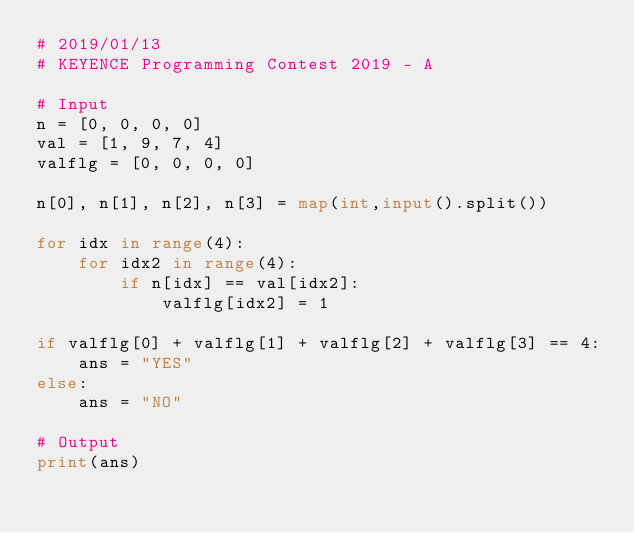Convert code to text. <code><loc_0><loc_0><loc_500><loc_500><_Python_># 2019/01/13
# KEYENCE Programming Contest 2019 - A
 
# Input
n = [0, 0, 0, 0]
val = [1, 9, 7, 4]
valflg = [0, 0, 0, 0]
 
n[0], n[1], n[2], n[3] = map(int,input().split())
 
for idx in range(4):
    for idx2 in range(4):
        if n[idx] == val[idx2]:
            valflg[idx2] = 1
 
if valflg[0] + valflg[1] + valflg[2] + valflg[3] == 4:
    ans = "YES"
else:
    ans = "NO"
    
# Output
print(ans)</code> 